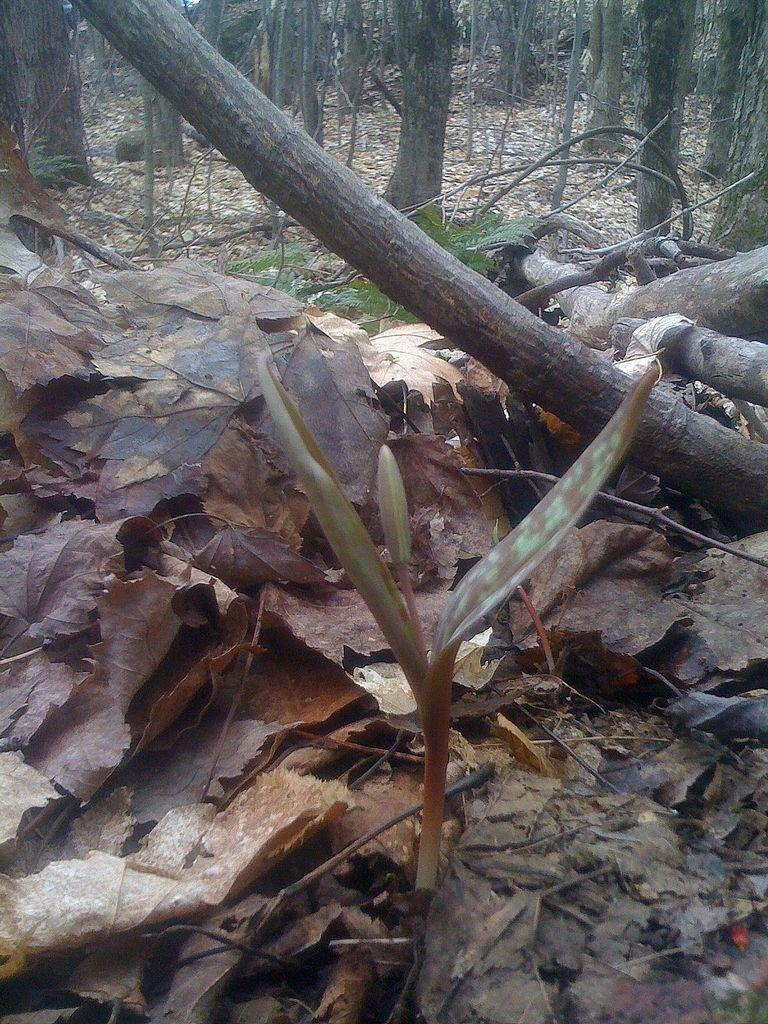What is the main subject in the middle of the image? There is a plant in the middle of the image. What can be seen behind the plant? There are leaves and stems visible behind the plant. What type of vegetation is visible at the top of the image? There are trees visible at the top of the image. What type of card is being used by the lawyer in the image? There is no card or lawyer present in the image; it features a plant with leaves and stems, and trees visible at the top. 